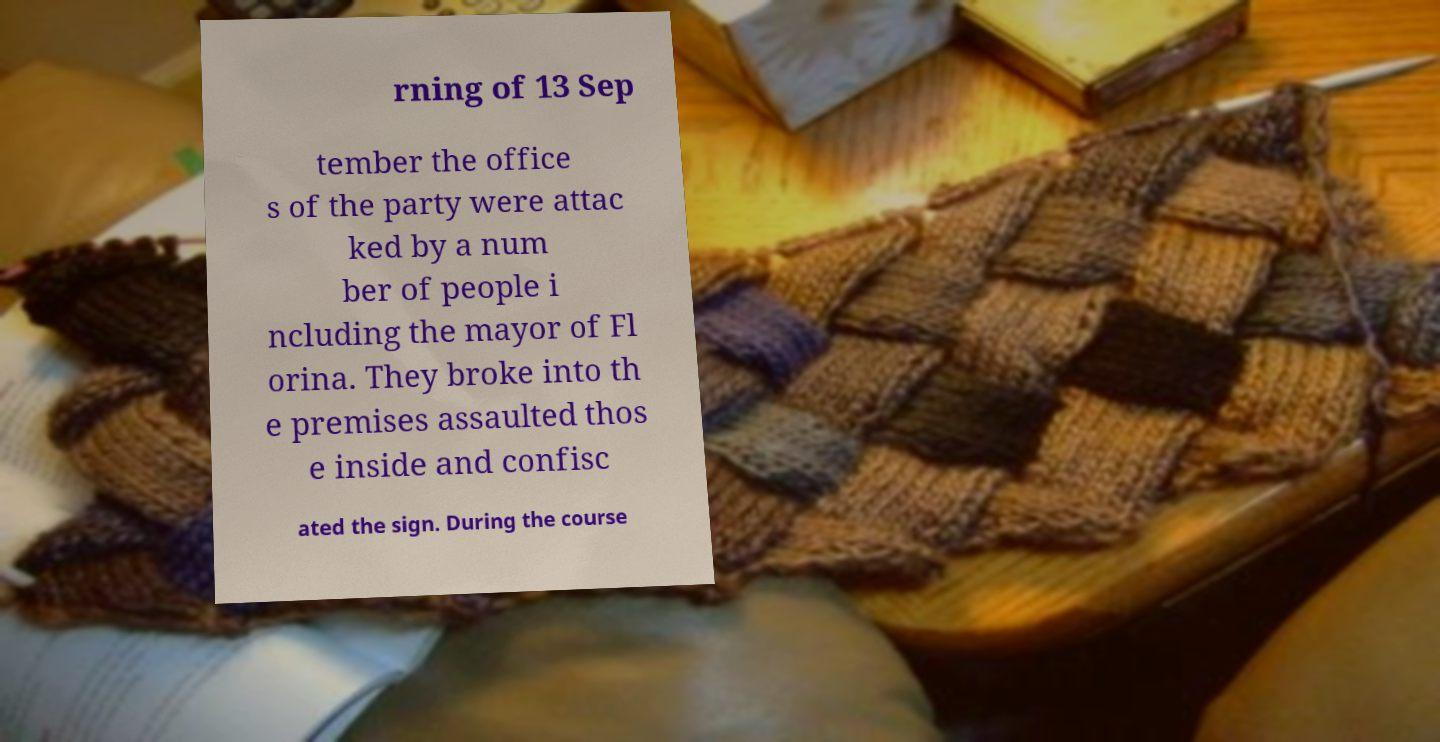Can you accurately transcribe the text from the provided image for me? rning of 13 Sep tember the office s of the party were attac ked by a num ber of people i ncluding the mayor of Fl orina. They broke into th e premises assaulted thos e inside and confisc ated the sign. During the course 